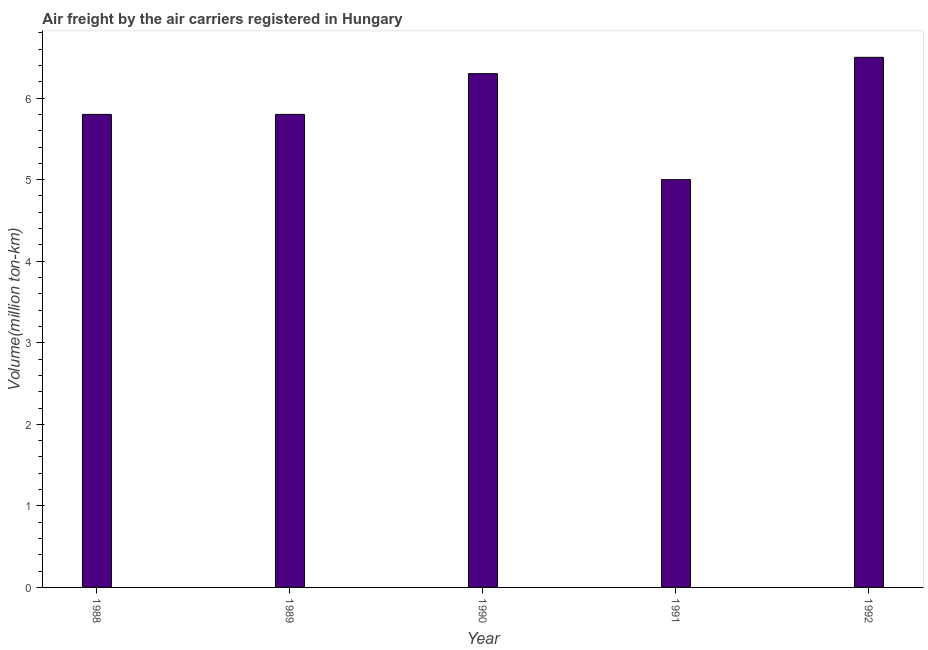What is the title of the graph?
Offer a very short reply. Air freight by the air carriers registered in Hungary. What is the label or title of the X-axis?
Offer a terse response. Year. What is the label or title of the Y-axis?
Offer a terse response. Volume(million ton-km). What is the air freight in 1990?
Ensure brevity in your answer.  6.3. Across all years, what is the maximum air freight?
Your answer should be very brief. 6.5. Across all years, what is the minimum air freight?
Your answer should be compact. 5. In which year was the air freight minimum?
Ensure brevity in your answer.  1991. What is the sum of the air freight?
Ensure brevity in your answer.  29.4. What is the difference between the air freight in 1989 and 1992?
Ensure brevity in your answer.  -0.7. What is the average air freight per year?
Offer a very short reply. 5.88. What is the median air freight?
Ensure brevity in your answer.  5.8. In how many years, is the air freight greater than 3.8 million ton-km?
Ensure brevity in your answer.  5. Do a majority of the years between 1991 and 1990 (inclusive) have air freight greater than 5.4 million ton-km?
Provide a short and direct response. No. What is the ratio of the air freight in 1988 to that in 1991?
Offer a very short reply. 1.16. Is the air freight in 1988 less than that in 1992?
Offer a terse response. Yes. Is the sum of the air freight in 1988 and 1992 greater than the maximum air freight across all years?
Offer a terse response. Yes. What is the difference between the highest and the lowest air freight?
Keep it short and to the point. 1.5. How many bars are there?
Your response must be concise. 5. What is the Volume(million ton-km) in 1988?
Your response must be concise. 5.8. What is the Volume(million ton-km) of 1989?
Provide a short and direct response. 5.8. What is the Volume(million ton-km) of 1990?
Your answer should be very brief. 6.3. What is the difference between the Volume(million ton-km) in 1988 and 1989?
Make the answer very short. 0. What is the difference between the Volume(million ton-km) in 1988 and 1991?
Ensure brevity in your answer.  0.8. What is the difference between the Volume(million ton-km) in 1988 and 1992?
Offer a terse response. -0.7. What is the difference between the Volume(million ton-km) in 1989 and 1991?
Keep it short and to the point. 0.8. What is the difference between the Volume(million ton-km) in 1989 and 1992?
Keep it short and to the point. -0.7. What is the ratio of the Volume(million ton-km) in 1988 to that in 1989?
Give a very brief answer. 1. What is the ratio of the Volume(million ton-km) in 1988 to that in 1990?
Your answer should be very brief. 0.92. What is the ratio of the Volume(million ton-km) in 1988 to that in 1991?
Provide a succinct answer. 1.16. What is the ratio of the Volume(million ton-km) in 1988 to that in 1992?
Give a very brief answer. 0.89. What is the ratio of the Volume(million ton-km) in 1989 to that in 1990?
Make the answer very short. 0.92. What is the ratio of the Volume(million ton-km) in 1989 to that in 1991?
Provide a succinct answer. 1.16. What is the ratio of the Volume(million ton-km) in 1989 to that in 1992?
Your answer should be very brief. 0.89. What is the ratio of the Volume(million ton-km) in 1990 to that in 1991?
Offer a very short reply. 1.26. What is the ratio of the Volume(million ton-km) in 1990 to that in 1992?
Ensure brevity in your answer.  0.97. What is the ratio of the Volume(million ton-km) in 1991 to that in 1992?
Ensure brevity in your answer.  0.77. 